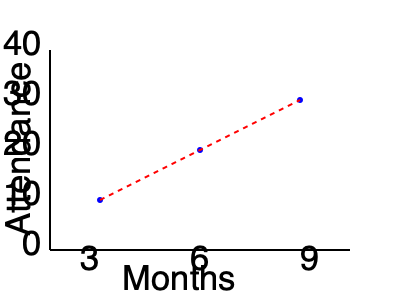As the computer science major managing the virtual book club, you're analyzing attendance trends. Calculate the slope of the line graph representing book club attendance over time, given that attendance increased from 10 members at 3 months to 30 members at 9 months. To calculate the slope of the line graph, we'll use the slope formula:

$$ \text{Slope} = \frac{\text{Change in y}}{\text{Change in x}} = \frac{y_2 - y_1}{x_2 - x_1} $$

Step 1: Identify the two points on the graph.
Point 1: $(x_1, y_1) = (3, 10)$
Point 2: $(x_2, y_2) = (9, 30)$

Step 2: Calculate the change in y (vertical change).
$\text{Change in y} = y_2 - y_1 = 30 - 10 = 20$

Step 3: Calculate the change in x (horizontal change).
$\text{Change in x} = x_2 - x_1 = 9 - 3 = 6$

Step 4: Apply the slope formula.
$$ \text{Slope} = \frac{\text{Change in y}}{\text{Change in x}} = \frac{20}{6} $$

Step 5: Simplify the fraction.
$$ \text{Slope} = \frac{20}{6} = \frac{10}{3} \approx 3.33 $$

The slope represents the rate of change in attendance per month. In this case, the book club gains approximately 3.33 members per month on average.
Answer: $\frac{10}{3}$ members/month 